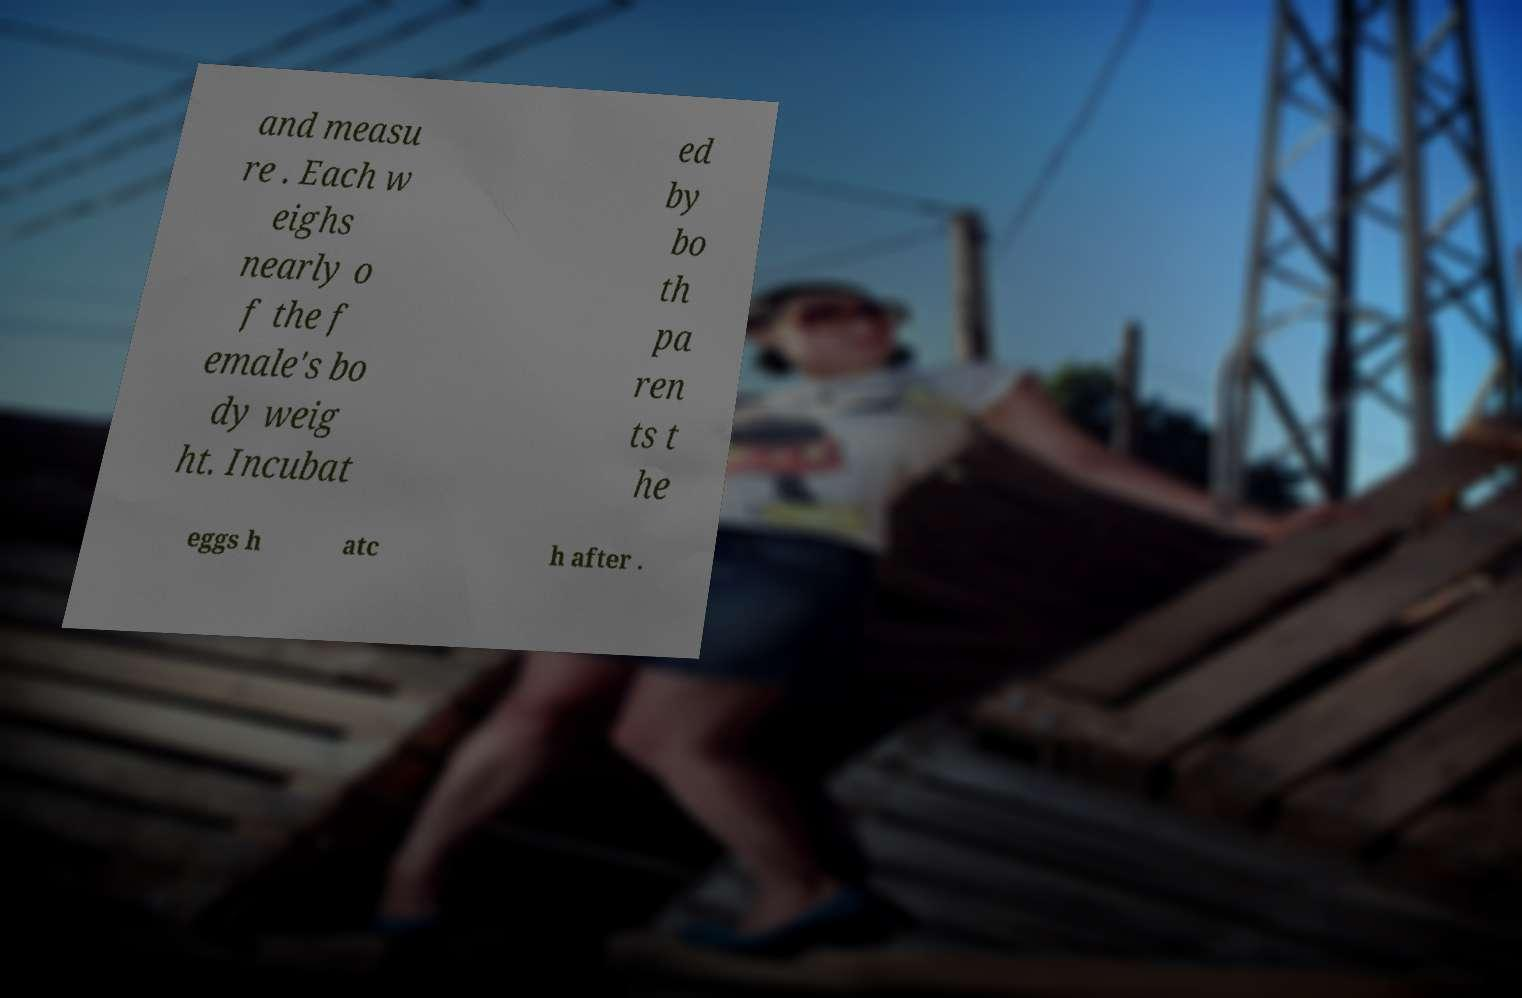Could you assist in decoding the text presented in this image and type it out clearly? and measu re . Each w eighs nearly o f the f emale's bo dy weig ht. Incubat ed by bo th pa ren ts t he eggs h atc h after . 